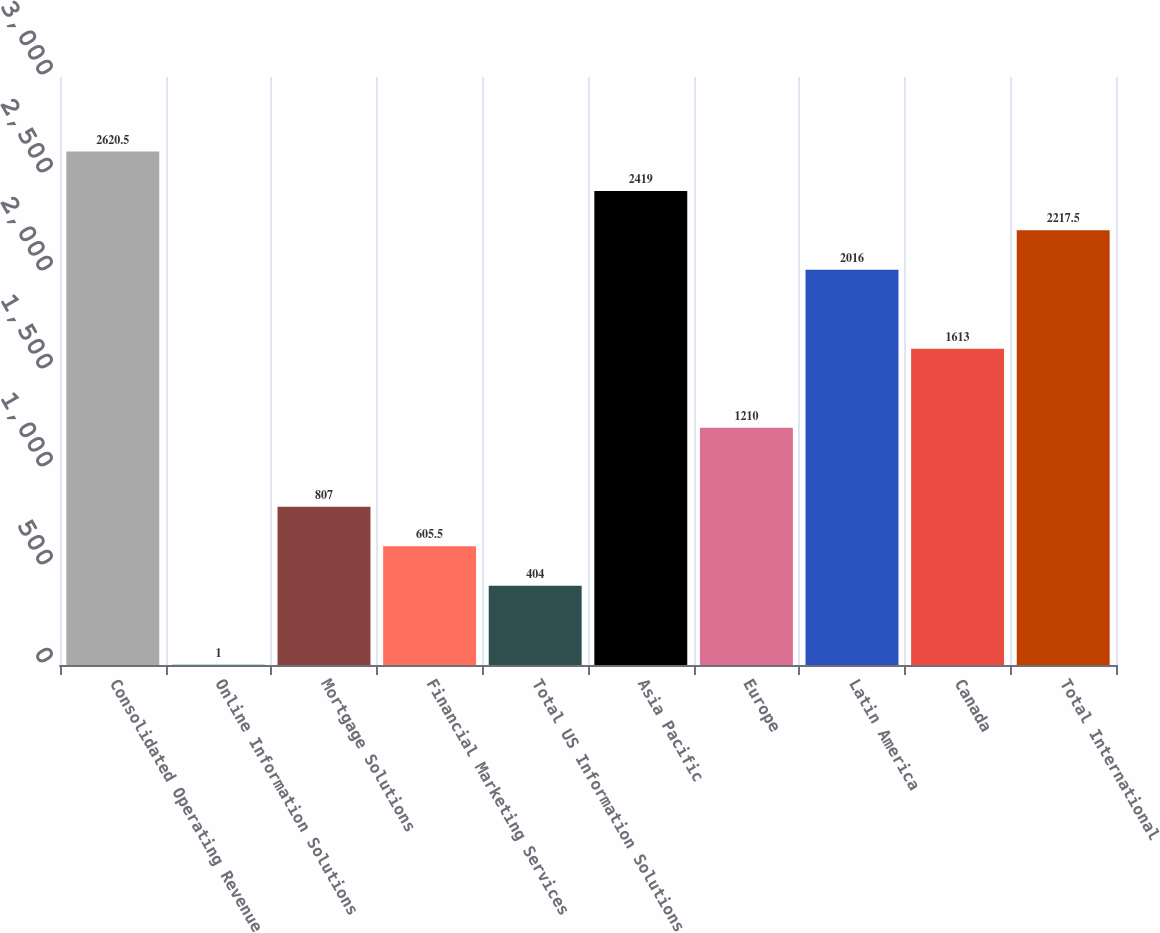Convert chart. <chart><loc_0><loc_0><loc_500><loc_500><bar_chart><fcel>Consolidated Operating Revenue<fcel>Online Information Solutions<fcel>Mortgage Solutions<fcel>Financial Marketing Services<fcel>Total US Information Solutions<fcel>Asia Pacific<fcel>Europe<fcel>Latin America<fcel>Canada<fcel>Total International<nl><fcel>2620.5<fcel>1<fcel>807<fcel>605.5<fcel>404<fcel>2419<fcel>1210<fcel>2016<fcel>1613<fcel>2217.5<nl></chart> 